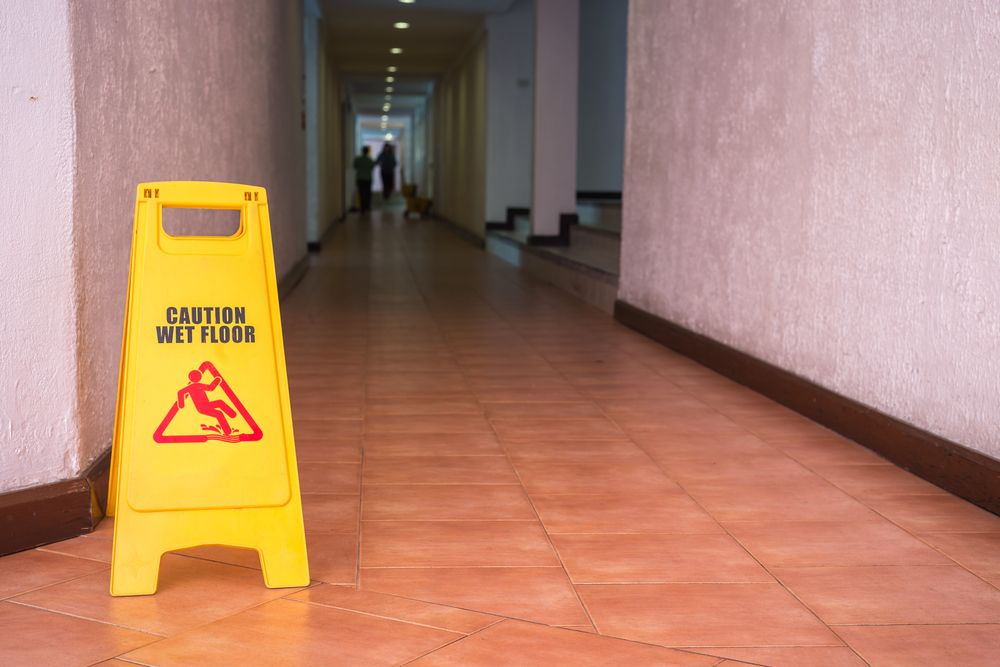Who might be responsible for placing the caution sign and ensuring such safety measures? Typically, a building's maintenance team or janitorial staff is responsible for placing caution signs and ensuring such safety measures. These individuals are usually trained to recognize potential hazards and respond accordingly to maintain a safe environment. They follow established protocols for setting up warning signs immediately upon identifying a risk, such as a wet floor. What could be some challenges they face while performing their duties? Some challenges that maintenance teams might face while performing their duties include managing large areas with limited staff, which can make timely responses difficult. They may also encounter non-compliance or indifference from building occupants who ignore safety signs or create hazards by not following guidelines (e.g., spilling water and not reporting it). In older buildings, outdated infrastructure can pose additional difficulties, such as malfunctioning lighting or inadequate plumbing systems. Additionally, maintenance teams must often deal with emergencies or urgent repairs, which can disrupt regular maintenance schedules and increase workload stress. 